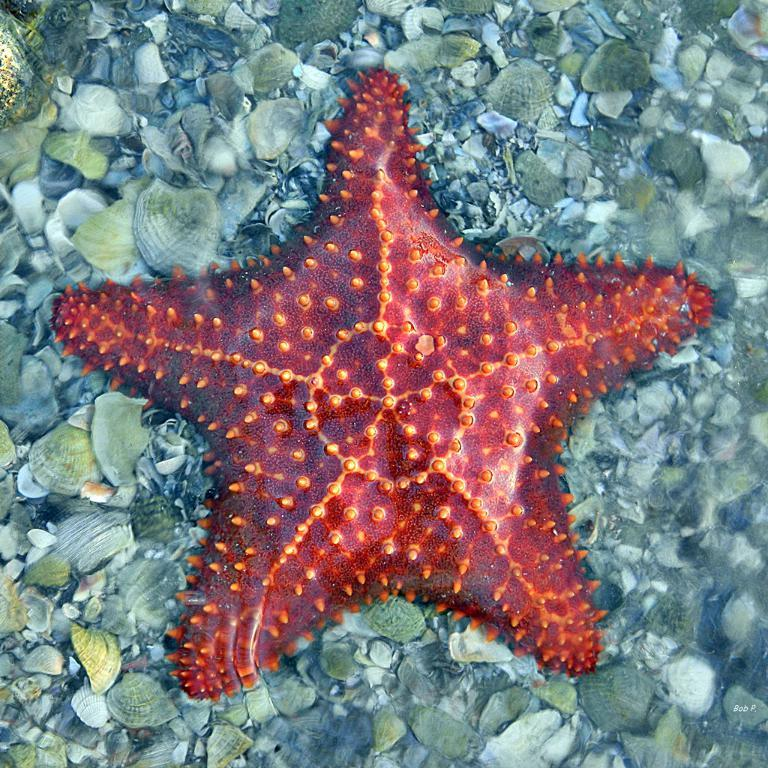What type of marine animals are present in the image? There are starfish in the image. What are the starfish placed on? The starfish are on shells. What type of paper is covering the starfish in the image? There is no paper present in the image, and the starfish are not covered. 